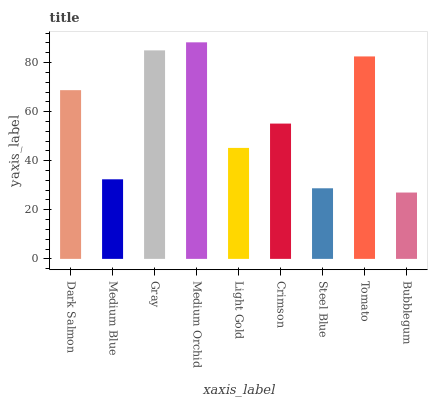Is Bubblegum the minimum?
Answer yes or no. Yes. Is Medium Orchid the maximum?
Answer yes or no. Yes. Is Medium Blue the minimum?
Answer yes or no. No. Is Medium Blue the maximum?
Answer yes or no. No. Is Dark Salmon greater than Medium Blue?
Answer yes or no. Yes. Is Medium Blue less than Dark Salmon?
Answer yes or no. Yes. Is Medium Blue greater than Dark Salmon?
Answer yes or no. No. Is Dark Salmon less than Medium Blue?
Answer yes or no. No. Is Crimson the high median?
Answer yes or no. Yes. Is Crimson the low median?
Answer yes or no. Yes. Is Steel Blue the high median?
Answer yes or no. No. Is Steel Blue the low median?
Answer yes or no. No. 